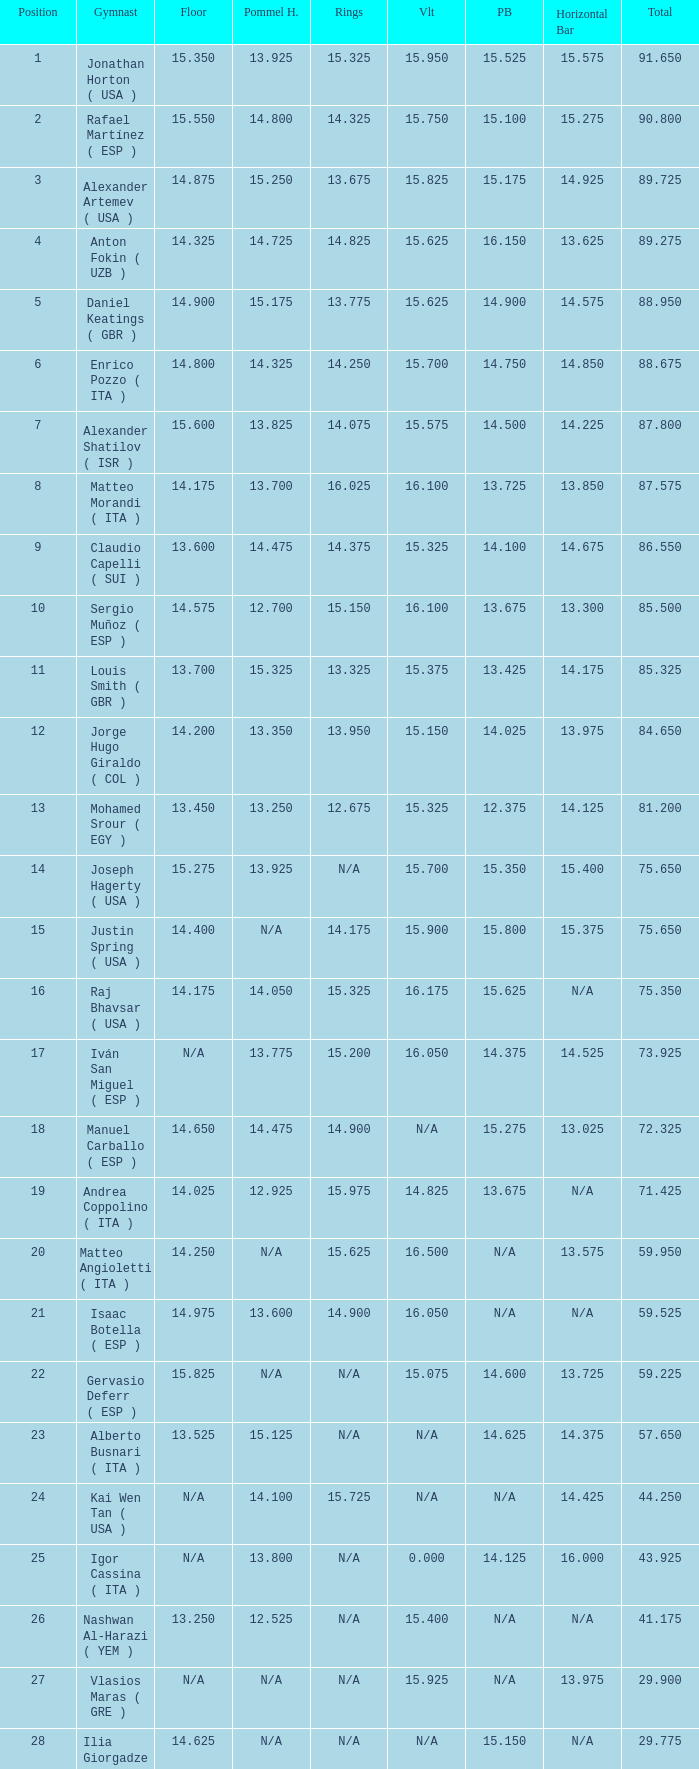If the floor number is 14.200, what is the number for the parallel bars? 14.025. 